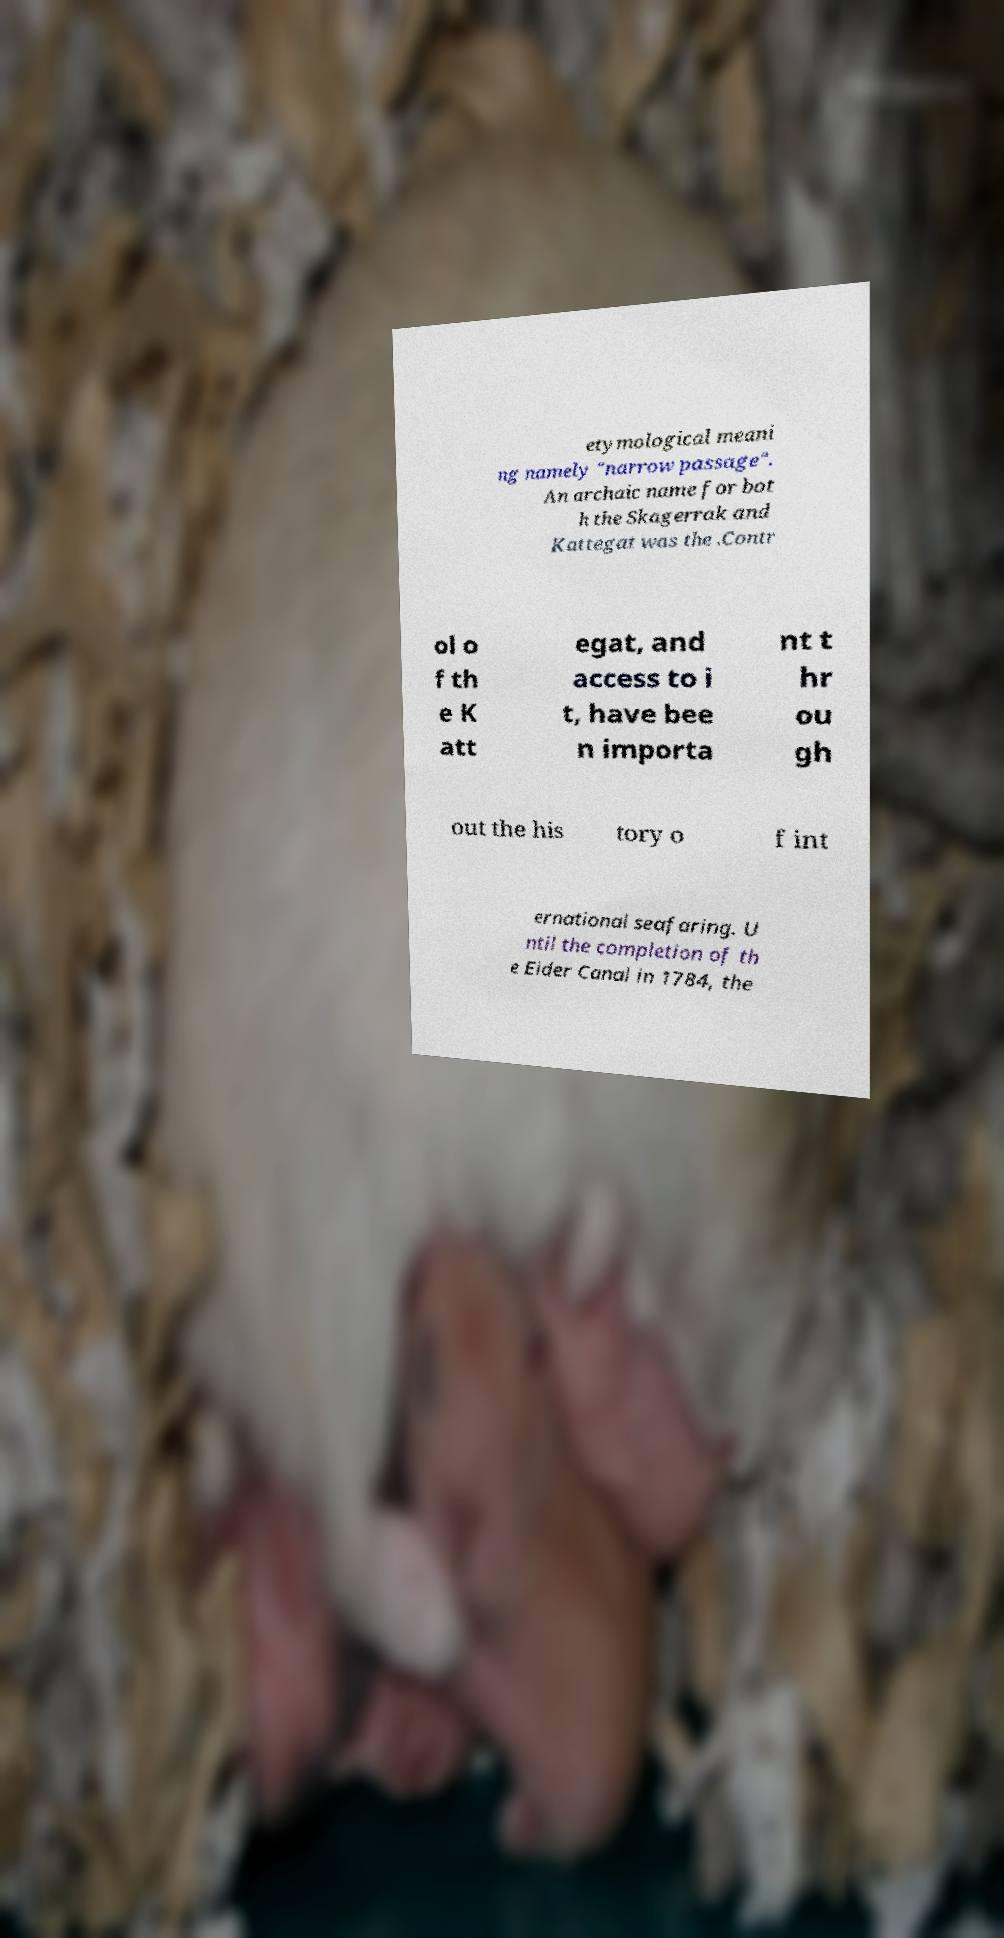Can you read and provide the text displayed in the image?This photo seems to have some interesting text. Can you extract and type it out for me? etymological meani ng namely "narrow passage". An archaic name for bot h the Skagerrak and Kattegat was the .Contr ol o f th e K att egat, and access to i t, have bee n importa nt t hr ou gh out the his tory o f int ernational seafaring. U ntil the completion of th e Eider Canal in 1784, the 